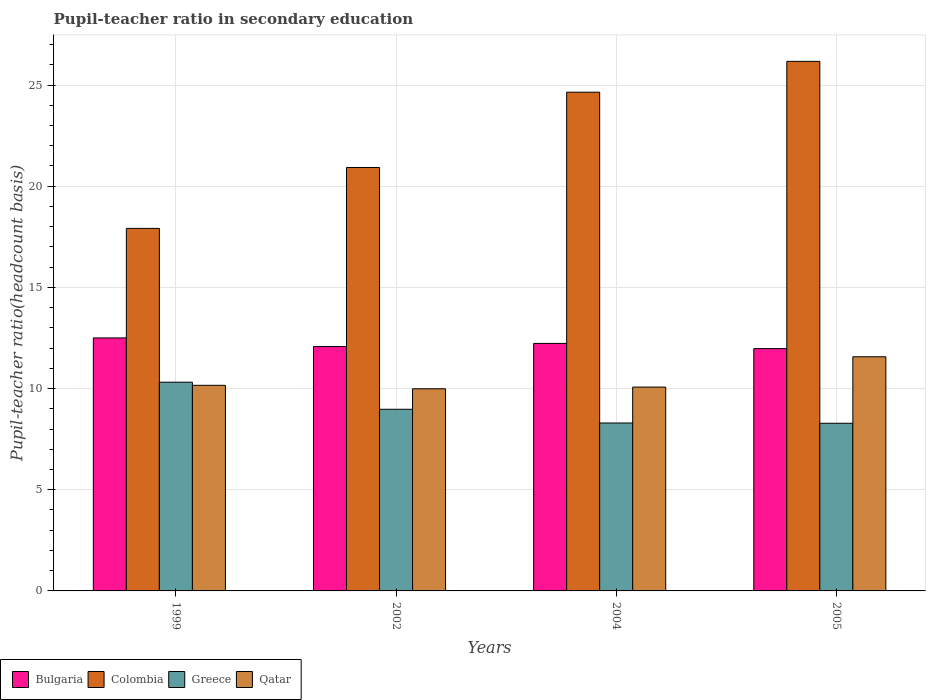Are the number of bars per tick equal to the number of legend labels?
Give a very brief answer. Yes. Are the number of bars on each tick of the X-axis equal?
Your answer should be very brief. Yes. How many bars are there on the 4th tick from the left?
Your answer should be very brief. 4. How many bars are there on the 1st tick from the right?
Your response must be concise. 4. In how many cases, is the number of bars for a given year not equal to the number of legend labels?
Your answer should be compact. 0. What is the pupil-teacher ratio in secondary education in Greece in 2002?
Your answer should be compact. 8.98. Across all years, what is the maximum pupil-teacher ratio in secondary education in Bulgaria?
Offer a terse response. 12.5. Across all years, what is the minimum pupil-teacher ratio in secondary education in Qatar?
Offer a very short reply. 9.99. In which year was the pupil-teacher ratio in secondary education in Colombia maximum?
Ensure brevity in your answer.  2005. What is the total pupil-teacher ratio in secondary education in Greece in the graph?
Your response must be concise. 35.88. What is the difference between the pupil-teacher ratio in secondary education in Qatar in 1999 and that in 2004?
Offer a terse response. 0.09. What is the difference between the pupil-teacher ratio in secondary education in Qatar in 2002 and the pupil-teacher ratio in secondary education in Greece in 1999?
Your answer should be very brief. -0.32. What is the average pupil-teacher ratio in secondary education in Greece per year?
Offer a terse response. 8.97. In the year 2004, what is the difference between the pupil-teacher ratio in secondary education in Colombia and pupil-teacher ratio in secondary education in Bulgaria?
Keep it short and to the point. 12.42. What is the ratio of the pupil-teacher ratio in secondary education in Colombia in 2002 to that in 2004?
Make the answer very short. 0.85. Is the difference between the pupil-teacher ratio in secondary education in Colombia in 2002 and 2004 greater than the difference between the pupil-teacher ratio in secondary education in Bulgaria in 2002 and 2004?
Provide a succinct answer. No. What is the difference between the highest and the second highest pupil-teacher ratio in secondary education in Qatar?
Offer a terse response. 1.41. What is the difference between the highest and the lowest pupil-teacher ratio in secondary education in Greece?
Offer a very short reply. 2.03. Is it the case that in every year, the sum of the pupil-teacher ratio in secondary education in Qatar and pupil-teacher ratio in secondary education in Greece is greater than the sum of pupil-teacher ratio in secondary education in Bulgaria and pupil-teacher ratio in secondary education in Colombia?
Keep it short and to the point. No. What does the 4th bar from the left in 1999 represents?
Keep it short and to the point. Qatar. What does the 2nd bar from the right in 2002 represents?
Provide a succinct answer. Greece. How many bars are there?
Your response must be concise. 16. What is the difference between two consecutive major ticks on the Y-axis?
Give a very brief answer. 5. Are the values on the major ticks of Y-axis written in scientific E-notation?
Offer a very short reply. No. How are the legend labels stacked?
Your response must be concise. Horizontal. What is the title of the graph?
Make the answer very short. Pupil-teacher ratio in secondary education. What is the label or title of the Y-axis?
Make the answer very short. Pupil-teacher ratio(headcount basis). What is the Pupil-teacher ratio(headcount basis) of Bulgaria in 1999?
Provide a succinct answer. 12.5. What is the Pupil-teacher ratio(headcount basis) in Colombia in 1999?
Keep it short and to the point. 17.92. What is the Pupil-teacher ratio(headcount basis) of Greece in 1999?
Your response must be concise. 10.32. What is the Pupil-teacher ratio(headcount basis) of Qatar in 1999?
Your answer should be compact. 10.16. What is the Pupil-teacher ratio(headcount basis) in Bulgaria in 2002?
Give a very brief answer. 12.08. What is the Pupil-teacher ratio(headcount basis) in Colombia in 2002?
Make the answer very short. 20.92. What is the Pupil-teacher ratio(headcount basis) in Greece in 2002?
Offer a very short reply. 8.98. What is the Pupil-teacher ratio(headcount basis) of Qatar in 2002?
Give a very brief answer. 9.99. What is the Pupil-teacher ratio(headcount basis) of Bulgaria in 2004?
Offer a terse response. 12.23. What is the Pupil-teacher ratio(headcount basis) in Colombia in 2004?
Make the answer very short. 24.65. What is the Pupil-teacher ratio(headcount basis) in Greece in 2004?
Make the answer very short. 8.3. What is the Pupil-teacher ratio(headcount basis) of Qatar in 2004?
Provide a short and direct response. 10.07. What is the Pupil-teacher ratio(headcount basis) in Bulgaria in 2005?
Provide a short and direct response. 11.98. What is the Pupil-teacher ratio(headcount basis) of Colombia in 2005?
Provide a short and direct response. 26.17. What is the Pupil-teacher ratio(headcount basis) of Greece in 2005?
Your response must be concise. 8.29. What is the Pupil-teacher ratio(headcount basis) in Qatar in 2005?
Give a very brief answer. 11.57. Across all years, what is the maximum Pupil-teacher ratio(headcount basis) of Bulgaria?
Ensure brevity in your answer.  12.5. Across all years, what is the maximum Pupil-teacher ratio(headcount basis) in Colombia?
Provide a short and direct response. 26.17. Across all years, what is the maximum Pupil-teacher ratio(headcount basis) of Greece?
Provide a succinct answer. 10.32. Across all years, what is the maximum Pupil-teacher ratio(headcount basis) in Qatar?
Your answer should be compact. 11.57. Across all years, what is the minimum Pupil-teacher ratio(headcount basis) in Bulgaria?
Make the answer very short. 11.98. Across all years, what is the minimum Pupil-teacher ratio(headcount basis) of Colombia?
Provide a succinct answer. 17.92. Across all years, what is the minimum Pupil-teacher ratio(headcount basis) of Greece?
Offer a terse response. 8.29. Across all years, what is the minimum Pupil-teacher ratio(headcount basis) of Qatar?
Give a very brief answer. 9.99. What is the total Pupil-teacher ratio(headcount basis) of Bulgaria in the graph?
Offer a terse response. 48.79. What is the total Pupil-teacher ratio(headcount basis) of Colombia in the graph?
Your response must be concise. 89.66. What is the total Pupil-teacher ratio(headcount basis) in Greece in the graph?
Your answer should be very brief. 35.88. What is the total Pupil-teacher ratio(headcount basis) of Qatar in the graph?
Your answer should be compact. 41.8. What is the difference between the Pupil-teacher ratio(headcount basis) in Bulgaria in 1999 and that in 2002?
Offer a terse response. 0.43. What is the difference between the Pupil-teacher ratio(headcount basis) of Colombia in 1999 and that in 2002?
Provide a short and direct response. -3.01. What is the difference between the Pupil-teacher ratio(headcount basis) in Greece in 1999 and that in 2002?
Ensure brevity in your answer.  1.34. What is the difference between the Pupil-teacher ratio(headcount basis) of Qatar in 1999 and that in 2002?
Your response must be concise. 0.17. What is the difference between the Pupil-teacher ratio(headcount basis) of Bulgaria in 1999 and that in 2004?
Your response must be concise. 0.27. What is the difference between the Pupil-teacher ratio(headcount basis) of Colombia in 1999 and that in 2004?
Offer a terse response. -6.73. What is the difference between the Pupil-teacher ratio(headcount basis) in Greece in 1999 and that in 2004?
Make the answer very short. 2.02. What is the difference between the Pupil-teacher ratio(headcount basis) in Qatar in 1999 and that in 2004?
Provide a succinct answer. 0.09. What is the difference between the Pupil-teacher ratio(headcount basis) in Bulgaria in 1999 and that in 2005?
Offer a very short reply. 0.53. What is the difference between the Pupil-teacher ratio(headcount basis) of Colombia in 1999 and that in 2005?
Keep it short and to the point. -8.25. What is the difference between the Pupil-teacher ratio(headcount basis) in Greece in 1999 and that in 2005?
Your response must be concise. 2.03. What is the difference between the Pupil-teacher ratio(headcount basis) of Qatar in 1999 and that in 2005?
Give a very brief answer. -1.41. What is the difference between the Pupil-teacher ratio(headcount basis) of Bulgaria in 2002 and that in 2004?
Keep it short and to the point. -0.15. What is the difference between the Pupil-teacher ratio(headcount basis) in Colombia in 2002 and that in 2004?
Provide a short and direct response. -3.72. What is the difference between the Pupil-teacher ratio(headcount basis) of Greece in 2002 and that in 2004?
Make the answer very short. 0.68. What is the difference between the Pupil-teacher ratio(headcount basis) in Qatar in 2002 and that in 2004?
Make the answer very short. -0.08. What is the difference between the Pupil-teacher ratio(headcount basis) of Bulgaria in 2002 and that in 2005?
Offer a terse response. 0.1. What is the difference between the Pupil-teacher ratio(headcount basis) in Colombia in 2002 and that in 2005?
Offer a very short reply. -5.25. What is the difference between the Pupil-teacher ratio(headcount basis) in Greece in 2002 and that in 2005?
Give a very brief answer. 0.69. What is the difference between the Pupil-teacher ratio(headcount basis) in Qatar in 2002 and that in 2005?
Keep it short and to the point. -1.58. What is the difference between the Pupil-teacher ratio(headcount basis) in Bulgaria in 2004 and that in 2005?
Your answer should be very brief. 0.26. What is the difference between the Pupil-teacher ratio(headcount basis) in Colombia in 2004 and that in 2005?
Your response must be concise. -1.52. What is the difference between the Pupil-teacher ratio(headcount basis) in Greece in 2004 and that in 2005?
Offer a terse response. 0.01. What is the difference between the Pupil-teacher ratio(headcount basis) of Qatar in 2004 and that in 2005?
Give a very brief answer. -1.5. What is the difference between the Pupil-teacher ratio(headcount basis) in Bulgaria in 1999 and the Pupil-teacher ratio(headcount basis) in Colombia in 2002?
Your response must be concise. -8.42. What is the difference between the Pupil-teacher ratio(headcount basis) in Bulgaria in 1999 and the Pupil-teacher ratio(headcount basis) in Greece in 2002?
Give a very brief answer. 3.53. What is the difference between the Pupil-teacher ratio(headcount basis) in Bulgaria in 1999 and the Pupil-teacher ratio(headcount basis) in Qatar in 2002?
Your answer should be compact. 2.51. What is the difference between the Pupil-teacher ratio(headcount basis) in Colombia in 1999 and the Pupil-teacher ratio(headcount basis) in Greece in 2002?
Provide a short and direct response. 8.94. What is the difference between the Pupil-teacher ratio(headcount basis) of Colombia in 1999 and the Pupil-teacher ratio(headcount basis) of Qatar in 2002?
Keep it short and to the point. 7.93. What is the difference between the Pupil-teacher ratio(headcount basis) of Greece in 1999 and the Pupil-teacher ratio(headcount basis) of Qatar in 2002?
Keep it short and to the point. 0.32. What is the difference between the Pupil-teacher ratio(headcount basis) of Bulgaria in 1999 and the Pupil-teacher ratio(headcount basis) of Colombia in 2004?
Offer a terse response. -12.14. What is the difference between the Pupil-teacher ratio(headcount basis) of Bulgaria in 1999 and the Pupil-teacher ratio(headcount basis) of Greece in 2004?
Keep it short and to the point. 4.2. What is the difference between the Pupil-teacher ratio(headcount basis) of Bulgaria in 1999 and the Pupil-teacher ratio(headcount basis) of Qatar in 2004?
Your answer should be compact. 2.43. What is the difference between the Pupil-teacher ratio(headcount basis) of Colombia in 1999 and the Pupil-teacher ratio(headcount basis) of Greece in 2004?
Provide a succinct answer. 9.62. What is the difference between the Pupil-teacher ratio(headcount basis) in Colombia in 1999 and the Pupil-teacher ratio(headcount basis) in Qatar in 2004?
Your answer should be compact. 7.84. What is the difference between the Pupil-teacher ratio(headcount basis) in Greece in 1999 and the Pupil-teacher ratio(headcount basis) in Qatar in 2004?
Make the answer very short. 0.24. What is the difference between the Pupil-teacher ratio(headcount basis) in Bulgaria in 1999 and the Pupil-teacher ratio(headcount basis) in Colombia in 2005?
Keep it short and to the point. -13.67. What is the difference between the Pupil-teacher ratio(headcount basis) of Bulgaria in 1999 and the Pupil-teacher ratio(headcount basis) of Greece in 2005?
Offer a terse response. 4.22. What is the difference between the Pupil-teacher ratio(headcount basis) in Bulgaria in 1999 and the Pupil-teacher ratio(headcount basis) in Qatar in 2005?
Give a very brief answer. 0.93. What is the difference between the Pupil-teacher ratio(headcount basis) of Colombia in 1999 and the Pupil-teacher ratio(headcount basis) of Greece in 2005?
Give a very brief answer. 9.63. What is the difference between the Pupil-teacher ratio(headcount basis) of Colombia in 1999 and the Pupil-teacher ratio(headcount basis) of Qatar in 2005?
Offer a very short reply. 6.35. What is the difference between the Pupil-teacher ratio(headcount basis) in Greece in 1999 and the Pupil-teacher ratio(headcount basis) in Qatar in 2005?
Give a very brief answer. -1.26. What is the difference between the Pupil-teacher ratio(headcount basis) of Bulgaria in 2002 and the Pupil-teacher ratio(headcount basis) of Colombia in 2004?
Your answer should be very brief. -12.57. What is the difference between the Pupil-teacher ratio(headcount basis) of Bulgaria in 2002 and the Pupil-teacher ratio(headcount basis) of Greece in 2004?
Provide a short and direct response. 3.78. What is the difference between the Pupil-teacher ratio(headcount basis) of Bulgaria in 2002 and the Pupil-teacher ratio(headcount basis) of Qatar in 2004?
Your answer should be compact. 2. What is the difference between the Pupil-teacher ratio(headcount basis) of Colombia in 2002 and the Pupil-teacher ratio(headcount basis) of Greece in 2004?
Ensure brevity in your answer.  12.63. What is the difference between the Pupil-teacher ratio(headcount basis) in Colombia in 2002 and the Pupil-teacher ratio(headcount basis) in Qatar in 2004?
Keep it short and to the point. 10.85. What is the difference between the Pupil-teacher ratio(headcount basis) of Greece in 2002 and the Pupil-teacher ratio(headcount basis) of Qatar in 2004?
Your response must be concise. -1.1. What is the difference between the Pupil-teacher ratio(headcount basis) of Bulgaria in 2002 and the Pupil-teacher ratio(headcount basis) of Colombia in 2005?
Ensure brevity in your answer.  -14.09. What is the difference between the Pupil-teacher ratio(headcount basis) in Bulgaria in 2002 and the Pupil-teacher ratio(headcount basis) in Greece in 2005?
Your response must be concise. 3.79. What is the difference between the Pupil-teacher ratio(headcount basis) of Bulgaria in 2002 and the Pupil-teacher ratio(headcount basis) of Qatar in 2005?
Make the answer very short. 0.51. What is the difference between the Pupil-teacher ratio(headcount basis) of Colombia in 2002 and the Pupil-teacher ratio(headcount basis) of Greece in 2005?
Give a very brief answer. 12.64. What is the difference between the Pupil-teacher ratio(headcount basis) of Colombia in 2002 and the Pupil-teacher ratio(headcount basis) of Qatar in 2005?
Provide a short and direct response. 9.35. What is the difference between the Pupil-teacher ratio(headcount basis) of Greece in 2002 and the Pupil-teacher ratio(headcount basis) of Qatar in 2005?
Provide a succinct answer. -2.59. What is the difference between the Pupil-teacher ratio(headcount basis) of Bulgaria in 2004 and the Pupil-teacher ratio(headcount basis) of Colombia in 2005?
Your answer should be very brief. -13.94. What is the difference between the Pupil-teacher ratio(headcount basis) in Bulgaria in 2004 and the Pupil-teacher ratio(headcount basis) in Greece in 2005?
Provide a short and direct response. 3.95. What is the difference between the Pupil-teacher ratio(headcount basis) in Bulgaria in 2004 and the Pupil-teacher ratio(headcount basis) in Qatar in 2005?
Your response must be concise. 0.66. What is the difference between the Pupil-teacher ratio(headcount basis) of Colombia in 2004 and the Pupil-teacher ratio(headcount basis) of Greece in 2005?
Give a very brief answer. 16.36. What is the difference between the Pupil-teacher ratio(headcount basis) in Colombia in 2004 and the Pupil-teacher ratio(headcount basis) in Qatar in 2005?
Give a very brief answer. 13.08. What is the difference between the Pupil-teacher ratio(headcount basis) in Greece in 2004 and the Pupil-teacher ratio(headcount basis) in Qatar in 2005?
Give a very brief answer. -3.27. What is the average Pupil-teacher ratio(headcount basis) in Bulgaria per year?
Provide a short and direct response. 12.2. What is the average Pupil-teacher ratio(headcount basis) in Colombia per year?
Your answer should be very brief. 22.42. What is the average Pupil-teacher ratio(headcount basis) in Greece per year?
Make the answer very short. 8.97. What is the average Pupil-teacher ratio(headcount basis) of Qatar per year?
Offer a very short reply. 10.45. In the year 1999, what is the difference between the Pupil-teacher ratio(headcount basis) in Bulgaria and Pupil-teacher ratio(headcount basis) in Colombia?
Make the answer very short. -5.41. In the year 1999, what is the difference between the Pupil-teacher ratio(headcount basis) in Bulgaria and Pupil-teacher ratio(headcount basis) in Greece?
Keep it short and to the point. 2.19. In the year 1999, what is the difference between the Pupil-teacher ratio(headcount basis) of Bulgaria and Pupil-teacher ratio(headcount basis) of Qatar?
Your response must be concise. 2.34. In the year 1999, what is the difference between the Pupil-teacher ratio(headcount basis) of Colombia and Pupil-teacher ratio(headcount basis) of Greece?
Provide a succinct answer. 7.6. In the year 1999, what is the difference between the Pupil-teacher ratio(headcount basis) of Colombia and Pupil-teacher ratio(headcount basis) of Qatar?
Keep it short and to the point. 7.76. In the year 1999, what is the difference between the Pupil-teacher ratio(headcount basis) of Greece and Pupil-teacher ratio(headcount basis) of Qatar?
Your response must be concise. 0.15. In the year 2002, what is the difference between the Pupil-teacher ratio(headcount basis) of Bulgaria and Pupil-teacher ratio(headcount basis) of Colombia?
Keep it short and to the point. -8.85. In the year 2002, what is the difference between the Pupil-teacher ratio(headcount basis) in Bulgaria and Pupil-teacher ratio(headcount basis) in Greece?
Ensure brevity in your answer.  3.1. In the year 2002, what is the difference between the Pupil-teacher ratio(headcount basis) in Bulgaria and Pupil-teacher ratio(headcount basis) in Qatar?
Offer a very short reply. 2.09. In the year 2002, what is the difference between the Pupil-teacher ratio(headcount basis) in Colombia and Pupil-teacher ratio(headcount basis) in Greece?
Your response must be concise. 11.95. In the year 2002, what is the difference between the Pupil-teacher ratio(headcount basis) in Colombia and Pupil-teacher ratio(headcount basis) in Qatar?
Keep it short and to the point. 10.93. In the year 2002, what is the difference between the Pupil-teacher ratio(headcount basis) in Greece and Pupil-teacher ratio(headcount basis) in Qatar?
Provide a short and direct response. -1.01. In the year 2004, what is the difference between the Pupil-teacher ratio(headcount basis) of Bulgaria and Pupil-teacher ratio(headcount basis) of Colombia?
Your answer should be compact. -12.42. In the year 2004, what is the difference between the Pupil-teacher ratio(headcount basis) of Bulgaria and Pupil-teacher ratio(headcount basis) of Greece?
Provide a succinct answer. 3.93. In the year 2004, what is the difference between the Pupil-teacher ratio(headcount basis) in Bulgaria and Pupil-teacher ratio(headcount basis) in Qatar?
Make the answer very short. 2.16. In the year 2004, what is the difference between the Pupil-teacher ratio(headcount basis) of Colombia and Pupil-teacher ratio(headcount basis) of Greece?
Give a very brief answer. 16.35. In the year 2004, what is the difference between the Pupil-teacher ratio(headcount basis) of Colombia and Pupil-teacher ratio(headcount basis) of Qatar?
Your answer should be very brief. 14.57. In the year 2004, what is the difference between the Pupil-teacher ratio(headcount basis) of Greece and Pupil-teacher ratio(headcount basis) of Qatar?
Keep it short and to the point. -1.77. In the year 2005, what is the difference between the Pupil-teacher ratio(headcount basis) in Bulgaria and Pupil-teacher ratio(headcount basis) in Colombia?
Your answer should be very brief. -14.2. In the year 2005, what is the difference between the Pupil-teacher ratio(headcount basis) of Bulgaria and Pupil-teacher ratio(headcount basis) of Greece?
Keep it short and to the point. 3.69. In the year 2005, what is the difference between the Pupil-teacher ratio(headcount basis) of Bulgaria and Pupil-teacher ratio(headcount basis) of Qatar?
Keep it short and to the point. 0.4. In the year 2005, what is the difference between the Pupil-teacher ratio(headcount basis) of Colombia and Pupil-teacher ratio(headcount basis) of Greece?
Offer a very short reply. 17.89. In the year 2005, what is the difference between the Pupil-teacher ratio(headcount basis) of Colombia and Pupil-teacher ratio(headcount basis) of Qatar?
Give a very brief answer. 14.6. In the year 2005, what is the difference between the Pupil-teacher ratio(headcount basis) of Greece and Pupil-teacher ratio(headcount basis) of Qatar?
Your answer should be very brief. -3.29. What is the ratio of the Pupil-teacher ratio(headcount basis) in Bulgaria in 1999 to that in 2002?
Offer a terse response. 1.04. What is the ratio of the Pupil-teacher ratio(headcount basis) in Colombia in 1999 to that in 2002?
Offer a terse response. 0.86. What is the ratio of the Pupil-teacher ratio(headcount basis) in Greece in 1999 to that in 2002?
Give a very brief answer. 1.15. What is the ratio of the Pupil-teacher ratio(headcount basis) of Qatar in 1999 to that in 2002?
Provide a short and direct response. 1.02. What is the ratio of the Pupil-teacher ratio(headcount basis) of Bulgaria in 1999 to that in 2004?
Make the answer very short. 1.02. What is the ratio of the Pupil-teacher ratio(headcount basis) in Colombia in 1999 to that in 2004?
Make the answer very short. 0.73. What is the ratio of the Pupil-teacher ratio(headcount basis) in Greece in 1999 to that in 2004?
Offer a terse response. 1.24. What is the ratio of the Pupil-teacher ratio(headcount basis) of Qatar in 1999 to that in 2004?
Ensure brevity in your answer.  1.01. What is the ratio of the Pupil-teacher ratio(headcount basis) in Bulgaria in 1999 to that in 2005?
Ensure brevity in your answer.  1.04. What is the ratio of the Pupil-teacher ratio(headcount basis) in Colombia in 1999 to that in 2005?
Your answer should be compact. 0.68. What is the ratio of the Pupil-teacher ratio(headcount basis) of Greece in 1999 to that in 2005?
Offer a terse response. 1.25. What is the ratio of the Pupil-teacher ratio(headcount basis) of Qatar in 1999 to that in 2005?
Make the answer very short. 0.88. What is the ratio of the Pupil-teacher ratio(headcount basis) of Bulgaria in 2002 to that in 2004?
Provide a succinct answer. 0.99. What is the ratio of the Pupil-teacher ratio(headcount basis) in Colombia in 2002 to that in 2004?
Make the answer very short. 0.85. What is the ratio of the Pupil-teacher ratio(headcount basis) of Greece in 2002 to that in 2004?
Your answer should be very brief. 1.08. What is the ratio of the Pupil-teacher ratio(headcount basis) in Bulgaria in 2002 to that in 2005?
Keep it short and to the point. 1.01. What is the ratio of the Pupil-teacher ratio(headcount basis) of Colombia in 2002 to that in 2005?
Provide a short and direct response. 0.8. What is the ratio of the Pupil-teacher ratio(headcount basis) of Greece in 2002 to that in 2005?
Offer a terse response. 1.08. What is the ratio of the Pupil-teacher ratio(headcount basis) of Qatar in 2002 to that in 2005?
Provide a short and direct response. 0.86. What is the ratio of the Pupil-teacher ratio(headcount basis) in Bulgaria in 2004 to that in 2005?
Ensure brevity in your answer.  1.02. What is the ratio of the Pupil-teacher ratio(headcount basis) in Colombia in 2004 to that in 2005?
Keep it short and to the point. 0.94. What is the ratio of the Pupil-teacher ratio(headcount basis) of Qatar in 2004 to that in 2005?
Ensure brevity in your answer.  0.87. What is the difference between the highest and the second highest Pupil-teacher ratio(headcount basis) of Bulgaria?
Keep it short and to the point. 0.27. What is the difference between the highest and the second highest Pupil-teacher ratio(headcount basis) of Colombia?
Provide a succinct answer. 1.52. What is the difference between the highest and the second highest Pupil-teacher ratio(headcount basis) of Greece?
Give a very brief answer. 1.34. What is the difference between the highest and the second highest Pupil-teacher ratio(headcount basis) in Qatar?
Keep it short and to the point. 1.41. What is the difference between the highest and the lowest Pupil-teacher ratio(headcount basis) in Bulgaria?
Keep it short and to the point. 0.53. What is the difference between the highest and the lowest Pupil-teacher ratio(headcount basis) in Colombia?
Give a very brief answer. 8.25. What is the difference between the highest and the lowest Pupil-teacher ratio(headcount basis) in Greece?
Your answer should be compact. 2.03. What is the difference between the highest and the lowest Pupil-teacher ratio(headcount basis) of Qatar?
Give a very brief answer. 1.58. 